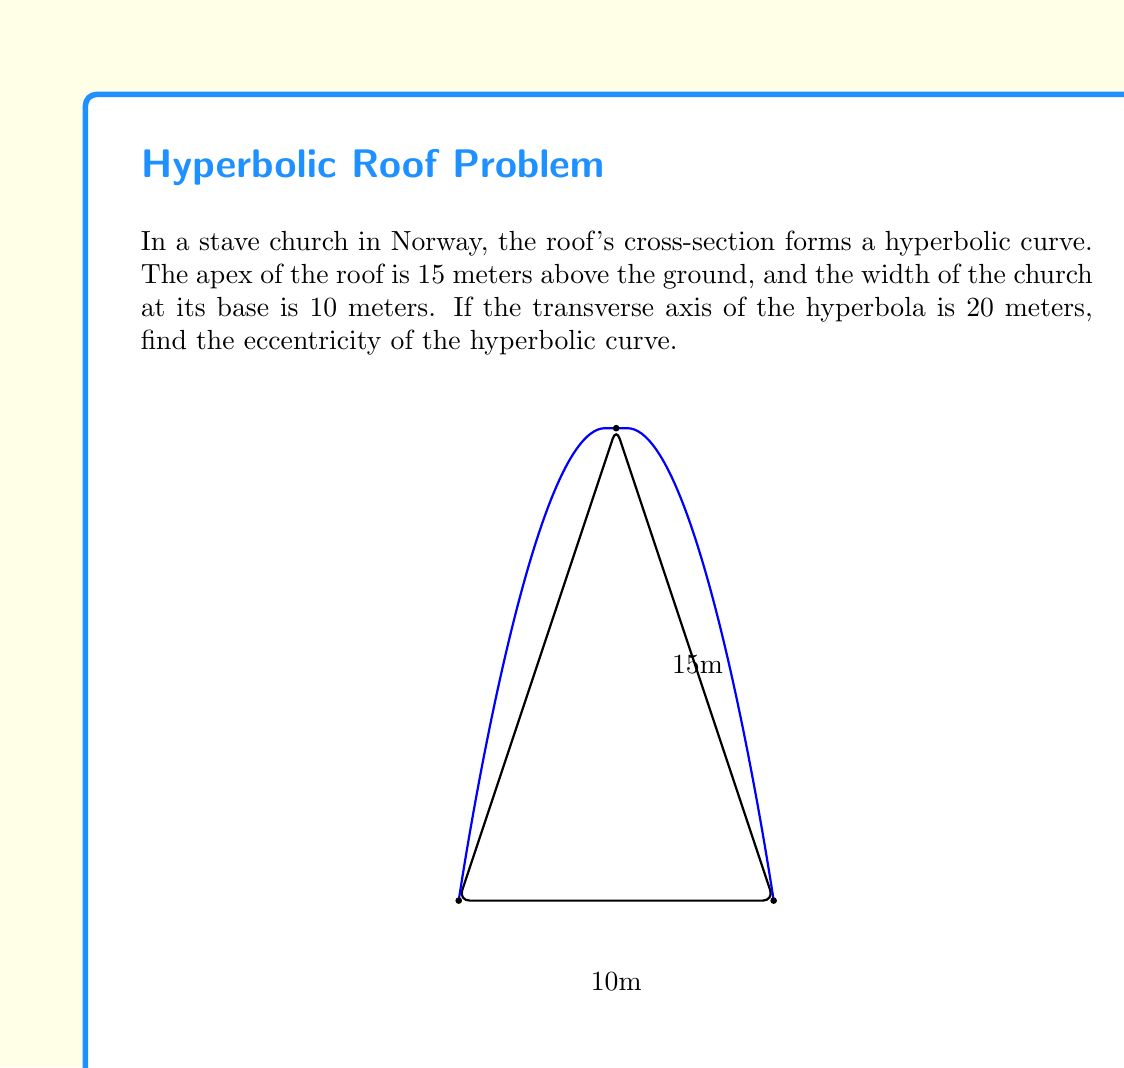Provide a solution to this math problem. Let's approach this step-by-step:

1) The standard form of a hyperbola with center $(0,0)$ is:

   $$\frac{x^2}{a^2} - \frac{y^2}{b^2} = 1$$

   where $a$ is half the length of the transverse axis.

2) We're given that the transverse axis is 20 meters, so $a = 10$.

3) The vertex of the hyperbola is at $(0,15)$, which corresponds to $(a,0)$ in the standard form. This means we need to rotate our coordinate system by 90°.

4) In this rotated system, we can find $b$ using the width of the church:
   
   $$\frac{5^2}{b^2} - \frac{0^2}{10^2} = 1$$
   
   $$\frac{25}{b^2} = 1$$
   
   $$b^2 = 25$$
   
   $$b = 5$$

5) The eccentricity $e$ of a hyperbola is given by:

   $$e = \sqrt{1 + \frac{b^2}{a^2}}$$

6) Substituting our values:

   $$e = \sqrt{1 + \frac{5^2}{10^2}}$$
   
   $$e = \sqrt{1 + \frac{25}{100}}$$
   
   $$e = \sqrt{1 + 0.25}$$
   
   $$e = \sqrt{1.25}$$
   
   $$e = \frac{\sqrt{5}}{2}$$
Answer: $\frac{\sqrt{5}}{2}$ 